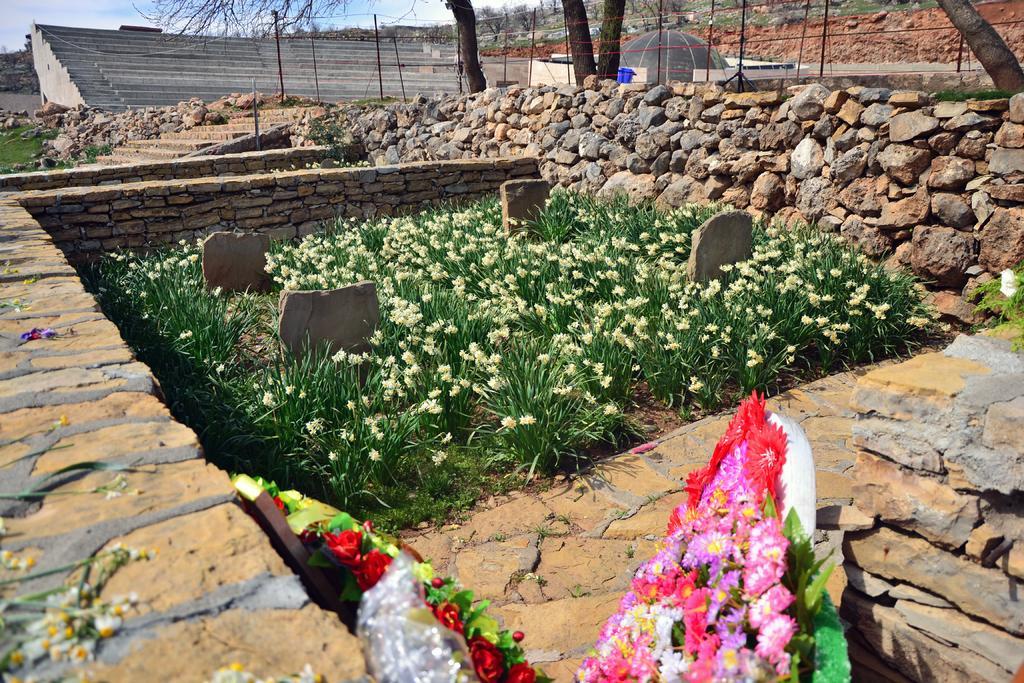In one or two sentences, can you explain what this image depicts? In the image on right side we can see some stones and plant with flowers. On left side there is a grass at bottom in middle there are some plants with flowers and a staircase and sky is on top. 